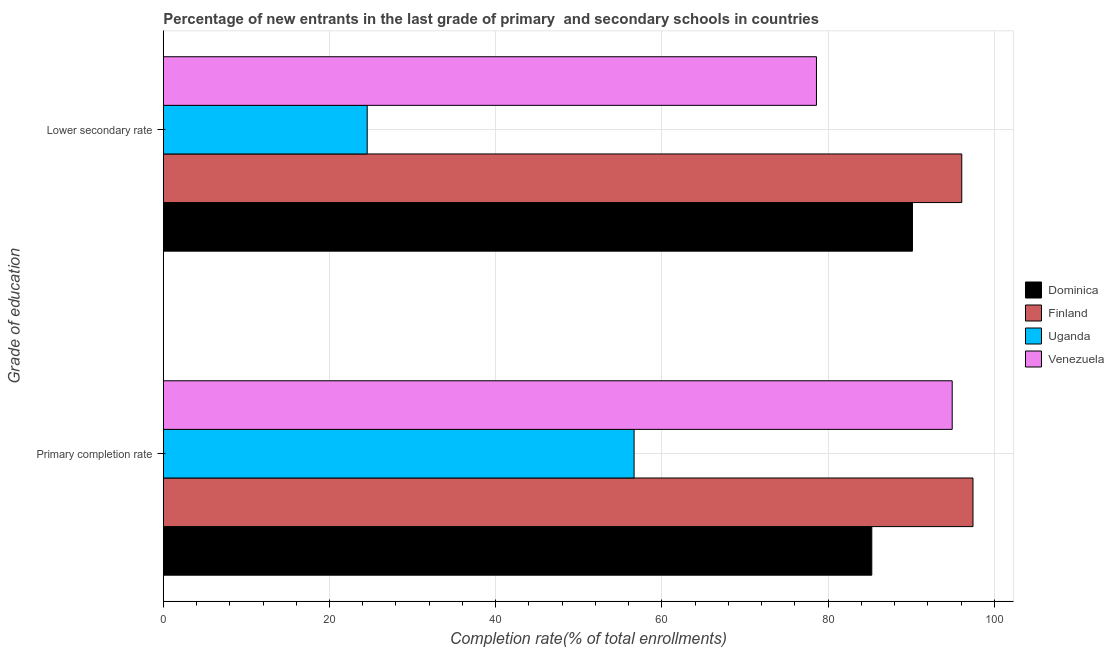How many different coloured bars are there?
Your response must be concise. 4. How many groups of bars are there?
Give a very brief answer. 2. Are the number of bars on each tick of the Y-axis equal?
Your answer should be compact. Yes. How many bars are there on the 2nd tick from the top?
Ensure brevity in your answer.  4. What is the label of the 2nd group of bars from the top?
Offer a terse response. Primary completion rate. What is the completion rate in secondary schools in Uganda?
Provide a succinct answer. 24.54. Across all countries, what is the maximum completion rate in secondary schools?
Provide a short and direct response. 96.08. Across all countries, what is the minimum completion rate in primary schools?
Keep it short and to the point. 56.65. In which country was the completion rate in secondary schools maximum?
Your answer should be compact. Finland. In which country was the completion rate in primary schools minimum?
Your answer should be very brief. Uganda. What is the total completion rate in primary schools in the graph?
Your answer should be compact. 334.26. What is the difference between the completion rate in primary schools in Dominica and that in Venezuela?
Your answer should be compact. -9.68. What is the difference between the completion rate in primary schools in Dominica and the completion rate in secondary schools in Venezuela?
Offer a very short reply. 6.66. What is the average completion rate in secondary schools per country?
Make the answer very short. 72.34. What is the difference between the completion rate in primary schools and completion rate in secondary schools in Finland?
Your answer should be compact. 1.35. What is the ratio of the completion rate in secondary schools in Uganda to that in Dominica?
Offer a terse response. 0.27. In how many countries, is the completion rate in secondary schools greater than the average completion rate in secondary schools taken over all countries?
Make the answer very short. 3. What does the 4th bar from the bottom in Lower secondary rate represents?
Ensure brevity in your answer.  Venezuela. How many bars are there?
Provide a short and direct response. 8. How many countries are there in the graph?
Offer a terse response. 4. Are the values on the major ticks of X-axis written in scientific E-notation?
Keep it short and to the point. No. What is the title of the graph?
Offer a very short reply. Percentage of new entrants in the last grade of primary  and secondary schools in countries. Does "Oman" appear as one of the legend labels in the graph?
Provide a succinct answer. No. What is the label or title of the X-axis?
Provide a succinct answer. Completion rate(% of total enrollments). What is the label or title of the Y-axis?
Provide a succinct answer. Grade of education. What is the Completion rate(% of total enrollments) in Dominica in Primary completion rate?
Your answer should be compact. 85.25. What is the Completion rate(% of total enrollments) in Finland in Primary completion rate?
Your answer should be very brief. 97.43. What is the Completion rate(% of total enrollments) in Uganda in Primary completion rate?
Make the answer very short. 56.65. What is the Completion rate(% of total enrollments) in Venezuela in Primary completion rate?
Provide a succinct answer. 94.93. What is the Completion rate(% of total enrollments) in Dominica in Lower secondary rate?
Your answer should be very brief. 90.14. What is the Completion rate(% of total enrollments) of Finland in Lower secondary rate?
Provide a short and direct response. 96.08. What is the Completion rate(% of total enrollments) of Uganda in Lower secondary rate?
Offer a very short reply. 24.54. What is the Completion rate(% of total enrollments) of Venezuela in Lower secondary rate?
Provide a short and direct response. 78.6. Across all Grade of education, what is the maximum Completion rate(% of total enrollments) in Dominica?
Your response must be concise. 90.14. Across all Grade of education, what is the maximum Completion rate(% of total enrollments) of Finland?
Make the answer very short. 97.43. Across all Grade of education, what is the maximum Completion rate(% of total enrollments) in Uganda?
Your response must be concise. 56.65. Across all Grade of education, what is the maximum Completion rate(% of total enrollments) in Venezuela?
Your answer should be very brief. 94.93. Across all Grade of education, what is the minimum Completion rate(% of total enrollments) in Dominica?
Give a very brief answer. 85.25. Across all Grade of education, what is the minimum Completion rate(% of total enrollments) of Finland?
Your answer should be compact. 96.08. Across all Grade of education, what is the minimum Completion rate(% of total enrollments) of Uganda?
Make the answer very short. 24.54. Across all Grade of education, what is the minimum Completion rate(% of total enrollments) in Venezuela?
Make the answer very short. 78.6. What is the total Completion rate(% of total enrollments) of Dominica in the graph?
Provide a succinct answer. 175.39. What is the total Completion rate(% of total enrollments) of Finland in the graph?
Offer a very short reply. 193.5. What is the total Completion rate(% of total enrollments) in Uganda in the graph?
Offer a terse response. 81.19. What is the total Completion rate(% of total enrollments) in Venezuela in the graph?
Offer a terse response. 173.52. What is the difference between the Completion rate(% of total enrollments) of Dominica in Primary completion rate and that in Lower secondary rate?
Provide a short and direct response. -4.89. What is the difference between the Completion rate(% of total enrollments) of Finland in Primary completion rate and that in Lower secondary rate?
Your response must be concise. 1.35. What is the difference between the Completion rate(% of total enrollments) in Uganda in Primary completion rate and that in Lower secondary rate?
Your answer should be compact. 32.11. What is the difference between the Completion rate(% of total enrollments) of Venezuela in Primary completion rate and that in Lower secondary rate?
Provide a succinct answer. 16.33. What is the difference between the Completion rate(% of total enrollments) in Dominica in Primary completion rate and the Completion rate(% of total enrollments) in Finland in Lower secondary rate?
Provide a short and direct response. -10.83. What is the difference between the Completion rate(% of total enrollments) of Dominica in Primary completion rate and the Completion rate(% of total enrollments) of Uganda in Lower secondary rate?
Provide a short and direct response. 60.71. What is the difference between the Completion rate(% of total enrollments) of Dominica in Primary completion rate and the Completion rate(% of total enrollments) of Venezuela in Lower secondary rate?
Your answer should be very brief. 6.66. What is the difference between the Completion rate(% of total enrollments) of Finland in Primary completion rate and the Completion rate(% of total enrollments) of Uganda in Lower secondary rate?
Keep it short and to the point. 72.89. What is the difference between the Completion rate(% of total enrollments) of Finland in Primary completion rate and the Completion rate(% of total enrollments) of Venezuela in Lower secondary rate?
Make the answer very short. 18.83. What is the difference between the Completion rate(% of total enrollments) in Uganda in Primary completion rate and the Completion rate(% of total enrollments) in Venezuela in Lower secondary rate?
Your answer should be very brief. -21.94. What is the average Completion rate(% of total enrollments) in Dominica per Grade of education?
Offer a very short reply. 87.7. What is the average Completion rate(% of total enrollments) of Finland per Grade of education?
Make the answer very short. 96.75. What is the average Completion rate(% of total enrollments) of Uganda per Grade of education?
Your response must be concise. 40.59. What is the average Completion rate(% of total enrollments) of Venezuela per Grade of education?
Give a very brief answer. 86.76. What is the difference between the Completion rate(% of total enrollments) in Dominica and Completion rate(% of total enrollments) in Finland in Primary completion rate?
Give a very brief answer. -12.18. What is the difference between the Completion rate(% of total enrollments) of Dominica and Completion rate(% of total enrollments) of Uganda in Primary completion rate?
Provide a succinct answer. 28.6. What is the difference between the Completion rate(% of total enrollments) in Dominica and Completion rate(% of total enrollments) in Venezuela in Primary completion rate?
Your answer should be compact. -9.68. What is the difference between the Completion rate(% of total enrollments) in Finland and Completion rate(% of total enrollments) in Uganda in Primary completion rate?
Offer a terse response. 40.78. What is the difference between the Completion rate(% of total enrollments) of Finland and Completion rate(% of total enrollments) of Venezuela in Primary completion rate?
Offer a very short reply. 2.5. What is the difference between the Completion rate(% of total enrollments) of Uganda and Completion rate(% of total enrollments) of Venezuela in Primary completion rate?
Your answer should be compact. -38.28. What is the difference between the Completion rate(% of total enrollments) of Dominica and Completion rate(% of total enrollments) of Finland in Lower secondary rate?
Offer a terse response. -5.93. What is the difference between the Completion rate(% of total enrollments) of Dominica and Completion rate(% of total enrollments) of Uganda in Lower secondary rate?
Provide a short and direct response. 65.61. What is the difference between the Completion rate(% of total enrollments) in Dominica and Completion rate(% of total enrollments) in Venezuela in Lower secondary rate?
Offer a terse response. 11.55. What is the difference between the Completion rate(% of total enrollments) of Finland and Completion rate(% of total enrollments) of Uganda in Lower secondary rate?
Make the answer very short. 71.54. What is the difference between the Completion rate(% of total enrollments) of Finland and Completion rate(% of total enrollments) of Venezuela in Lower secondary rate?
Your answer should be very brief. 17.48. What is the difference between the Completion rate(% of total enrollments) in Uganda and Completion rate(% of total enrollments) in Venezuela in Lower secondary rate?
Provide a succinct answer. -54.06. What is the ratio of the Completion rate(% of total enrollments) in Dominica in Primary completion rate to that in Lower secondary rate?
Offer a very short reply. 0.95. What is the ratio of the Completion rate(% of total enrollments) of Finland in Primary completion rate to that in Lower secondary rate?
Give a very brief answer. 1.01. What is the ratio of the Completion rate(% of total enrollments) of Uganda in Primary completion rate to that in Lower secondary rate?
Give a very brief answer. 2.31. What is the ratio of the Completion rate(% of total enrollments) of Venezuela in Primary completion rate to that in Lower secondary rate?
Give a very brief answer. 1.21. What is the difference between the highest and the second highest Completion rate(% of total enrollments) of Dominica?
Provide a succinct answer. 4.89. What is the difference between the highest and the second highest Completion rate(% of total enrollments) in Finland?
Offer a terse response. 1.35. What is the difference between the highest and the second highest Completion rate(% of total enrollments) of Uganda?
Give a very brief answer. 32.11. What is the difference between the highest and the second highest Completion rate(% of total enrollments) in Venezuela?
Ensure brevity in your answer.  16.33. What is the difference between the highest and the lowest Completion rate(% of total enrollments) in Dominica?
Offer a very short reply. 4.89. What is the difference between the highest and the lowest Completion rate(% of total enrollments) in Finland?
Make the answer very short. 1.35. What is the difference between the highest and the lowest Completion rate(% of total enrollments) of Uganda?
Provide a succinct answer. 32.11. What is the difference between the highest and the lowest Completion rate(% of total enrollments) in Venezuela?
Keep it short and to the point. 16.33. 